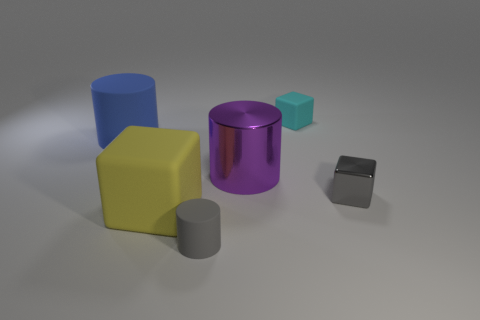Is the big object that is to the right of the small cylinder made of the same material as the gray object that is to the right of the large purple metal thing?
Your response must be concise. Yes. How big is the gray object that is behind the tiny gray thing in front of the big thing in front of the shiny cube?
Offer a very short reply. Small. How many purple objects have the same material as the small cyan thing?
Your response must be concise. 0. Is the number of big blue rubber cylinders less than the number of rubber things?
Your response must be concise. Yes. What is the size of the other metallic object that is the same shape as the yellow thing?
Provide a short and direct response. Small. Are the tiny thing in front of the big yellow cube and the big purple object made of the same material?
Your response must be concise. No. Is the shape of the blue matte thing the same as the big yellow thing?
Your answer should be compact. No. What number of objects are either gray cylinders in front of the yellow cube or tiny cyan matte things?
Your answer should be very brief. 2. What is the size of the purple cylinder that is made of the same material as the tiny gray block?
Offer a very short reply. Large. How many large metallic objects have the same color as the metal cube?
Provide a succinct answer. 0. 